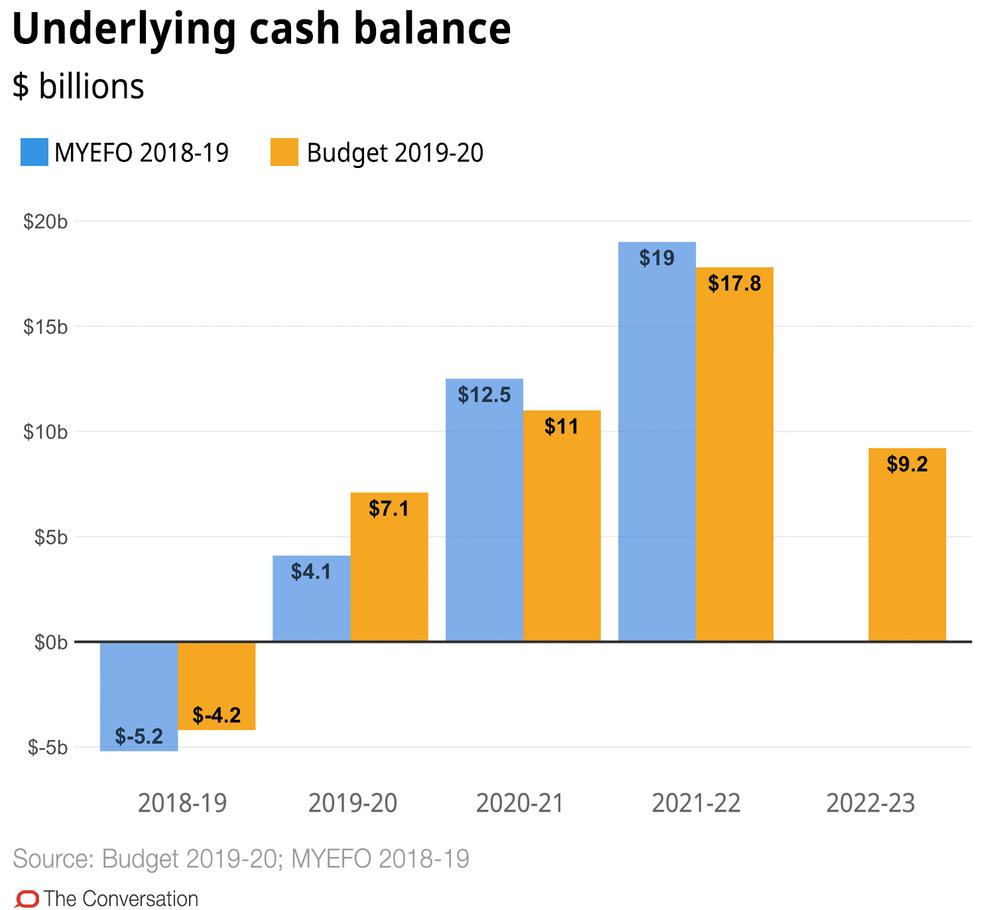List a handful of essential elements in this visual. The lowest underlying cash balance was reached in the financial year 2018-19, as stated in the Mid-Year Economic and Fiscal Outlook (MYEFO). The predicted budget for 2019-2020 is $9.2 billion, and it is expected to increase to $9.8 billion in 2022-2023. The maximum value of the Mid-Year Economic and Fiscal Outlook (MYEFO) for the year 2021-22 in billions of dollars is $19. 